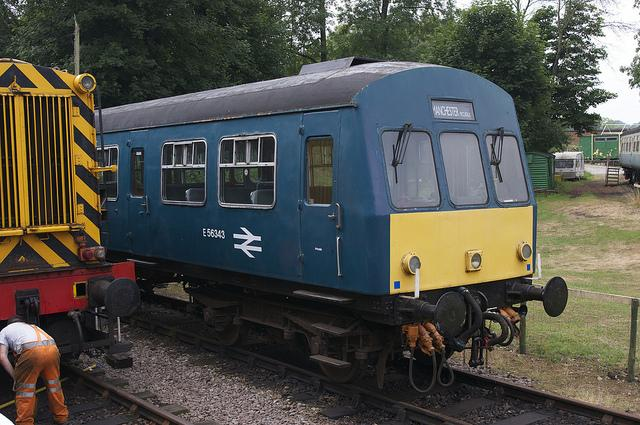What are the black circular pieces on the front of the train?

Choices:
A) frisbees
B) bumpers
C) guns
D) holders bumpers 